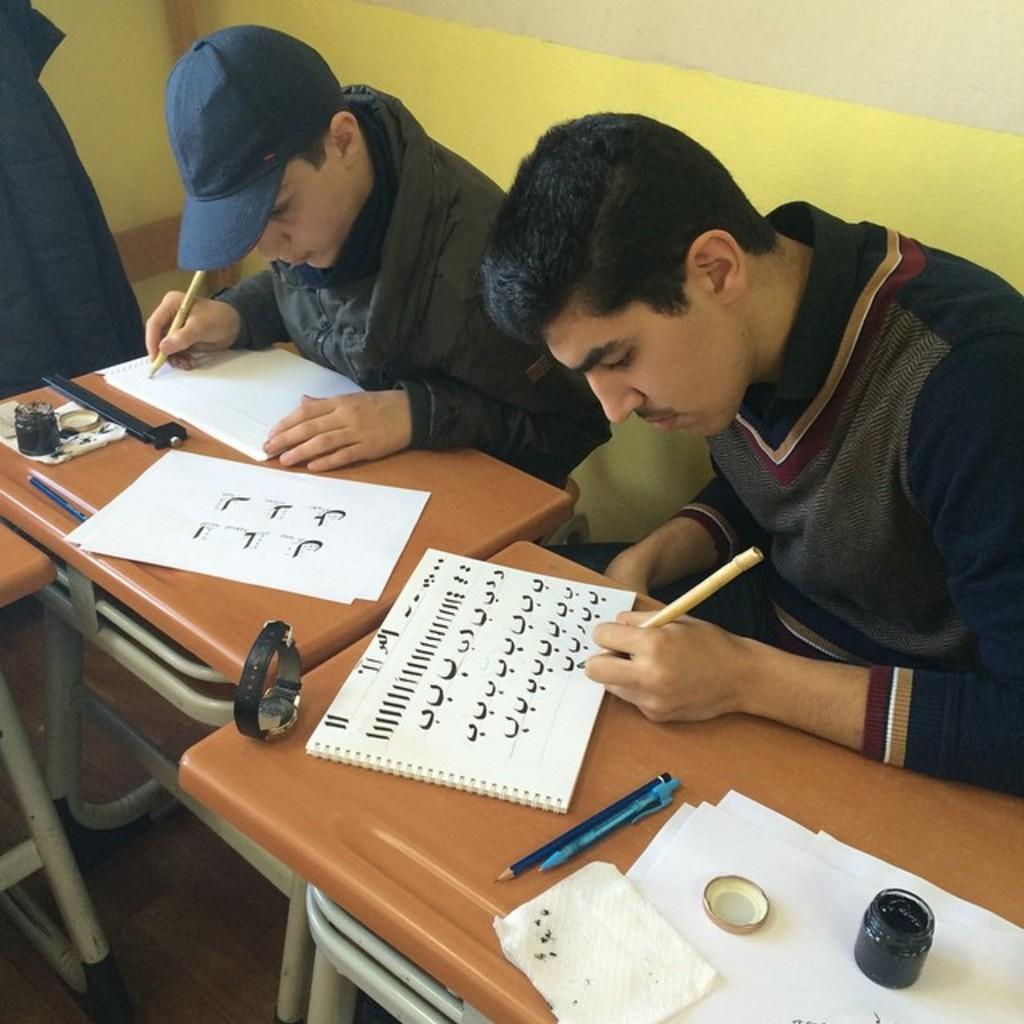How many people are present in the image? There are two guys sitting in the image. What are the guys doing in the image? The guys are writing on paper. What objects can be seen on the table in the image? There is a watch, an ink bottle, pens, and pencils on the table. What type of suit is the porter wearing in the image? There is no porter present in the image, and therefore no suit can be observed. What is the top item on the table in the image? The provided facts do not specify the arrangement of the objects on the table, so it is not possible to determine the top item. 